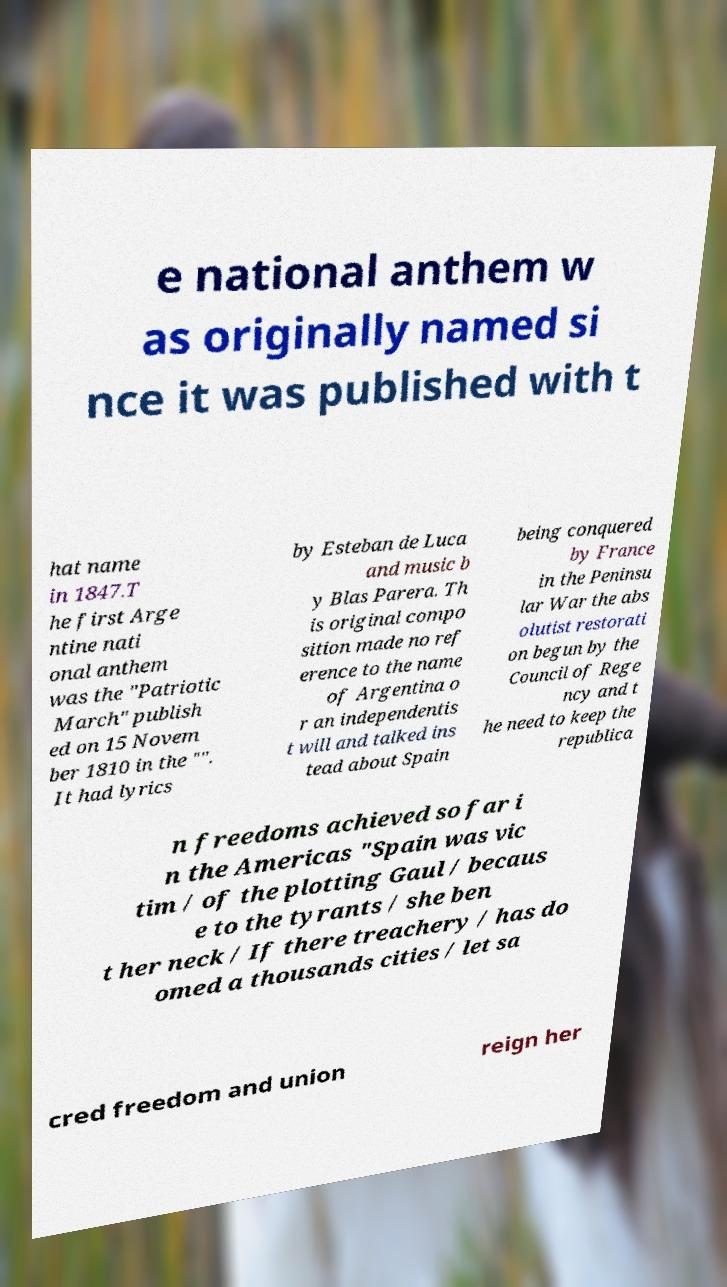What messages or text are displayed in this image? I need them in a readable, typed format. e national anthem w as originally named si nce it was published with t hat name in 1847.T he first Arge ntine nati onal anthem was the "Patriotic March" publish ed on 15 Novem ber 1810 in the "". It had lyrics by Esteban de Luca and music b y Blas Parera. Th is original compo sition made no ref erence to the name of Argentina o r an independentis t will and talked ins tead about Spain being conquered by France in the Peninsu lar War the abs olutist restorati on begun by the Council of Rege ncy and t he need to keep the republica n freedoms achieved so far i n the Americas "Spain was vic tim / of the plotting Gaul / becaus e to the tyrants / she ben t her neck / If there treachery / has do omed a thousands cities / let sa cred freedom and union reign her 